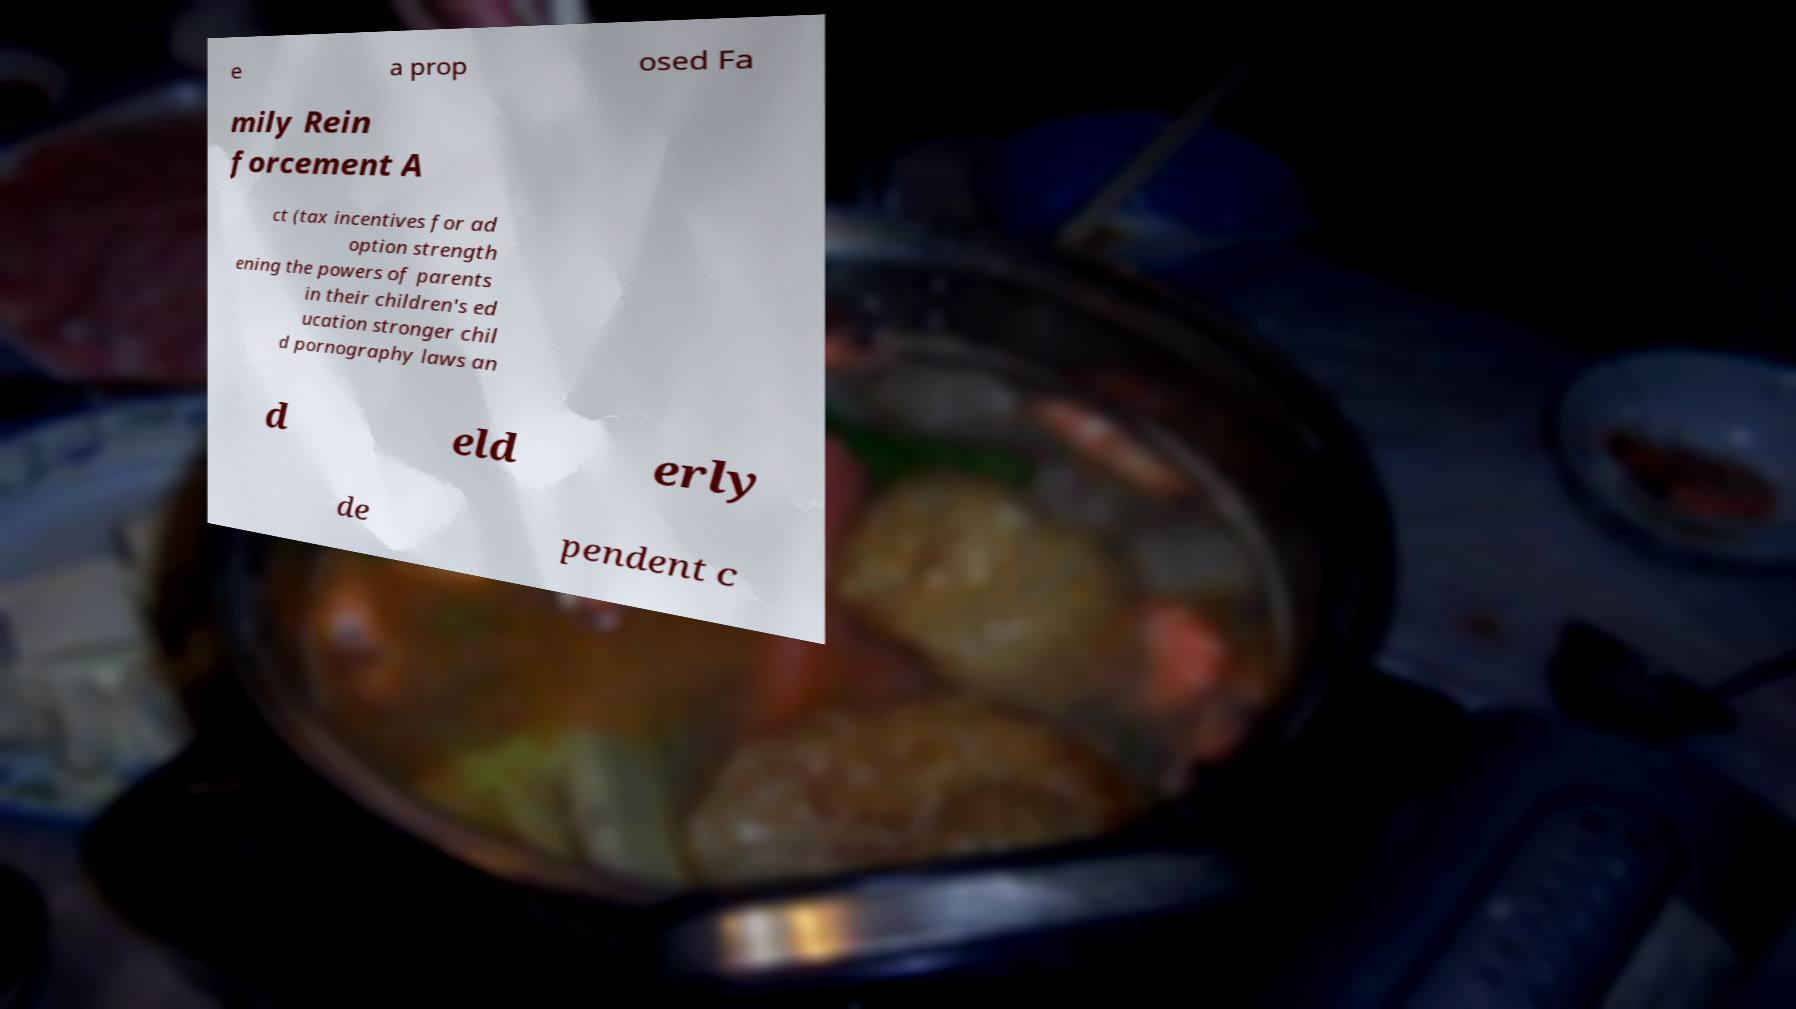What messages or text are displayed in this image? I need them in a readable, typed format. e a prop osed Fa mily Rein forcement A ct (tax incentives for ad option strength ening the powers of parents in their children's ed ucation stronger chil d pornography laws an d eld erly de pendent c 